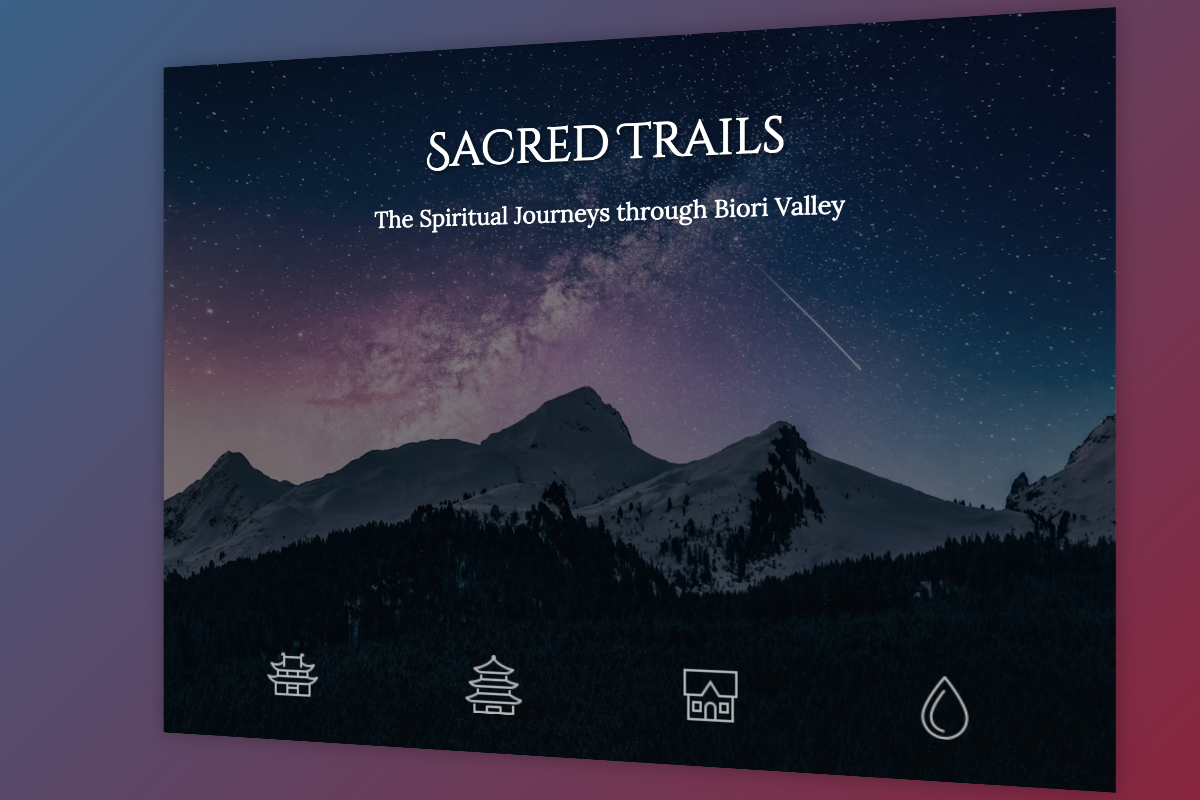What is the title of the book? The title of the book is prominently displayed on the cover.
Answer: Sacred Trails What does the subtitle of the book say? The subtitle gives additional context about the content of the book.
Answer: The Spiritual Journeys through Biori Valley What is the color of the background gradient? The background gradient blends two specific colors.
Answer: Dark blue and burgundy How many symbols are displayed at the bottom of the cover? The cover features symbols representing cultural landmarks.
Answer: Four What type of cultural landmark does the first symbol represent? The first symbol in the sequence represents a specific type of cultural architecture.
Answer: Ancient Hindu Temples Which symbol represents a natural feature? The symbol indicates a specific kind of natural resource or area.
Answer: Sacred Natural Springs What visual effect does the cover exhibit upon hover? The cover has a specific animation effect when interacted with.
Answer: Rotate What is the primary visual theme of the cover? The overall design and imagery evoke a specific atmosphere related to the book's theme.
Answer: Spiritual journey Which fonts are used for the title and subtitle? The title and subtitle use distinct font styles for emphasis.
Answer: Cinzel Decorative and Lora 